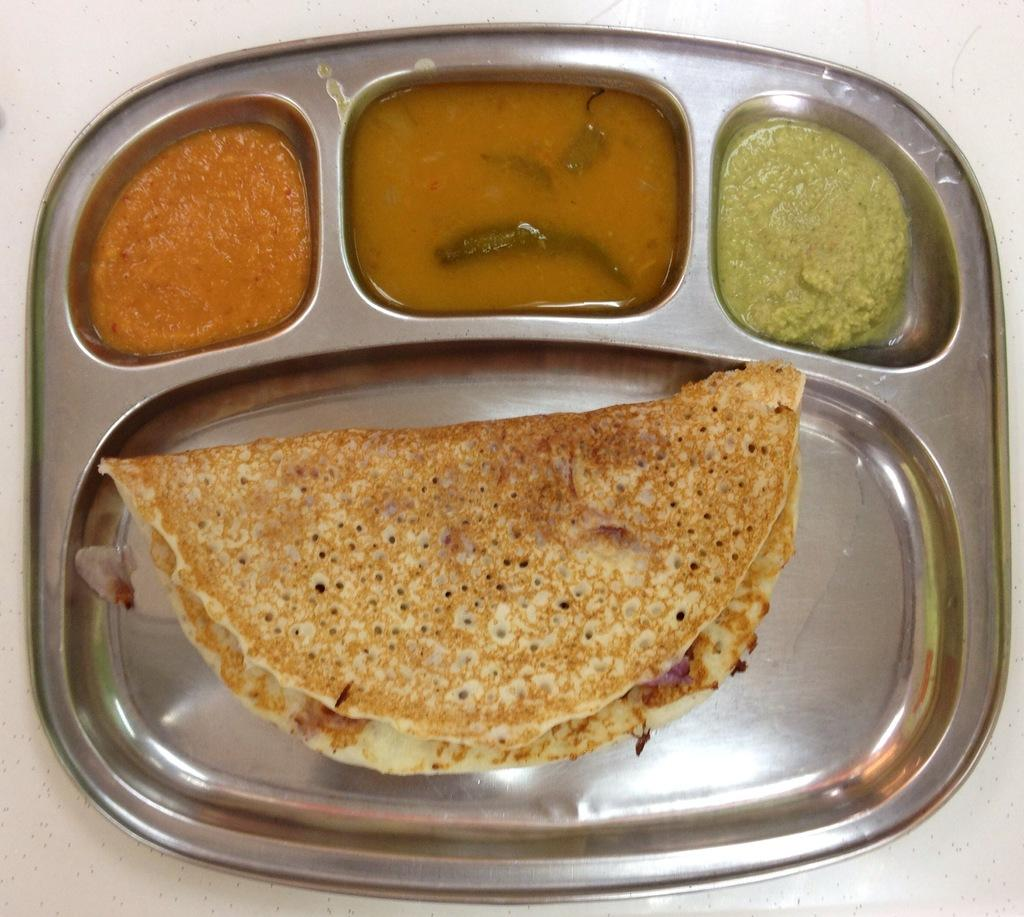What is on the plate that is visible in the image? The plate contains a food item and two chutneys. What type of food item is on the plate? There is a liquid food item on the plate. Where is the plate located in the image? The plate is on a platform. What decision is being made by the icicle in the image? There is no icicle present in the image, so no decision can be made by it. 